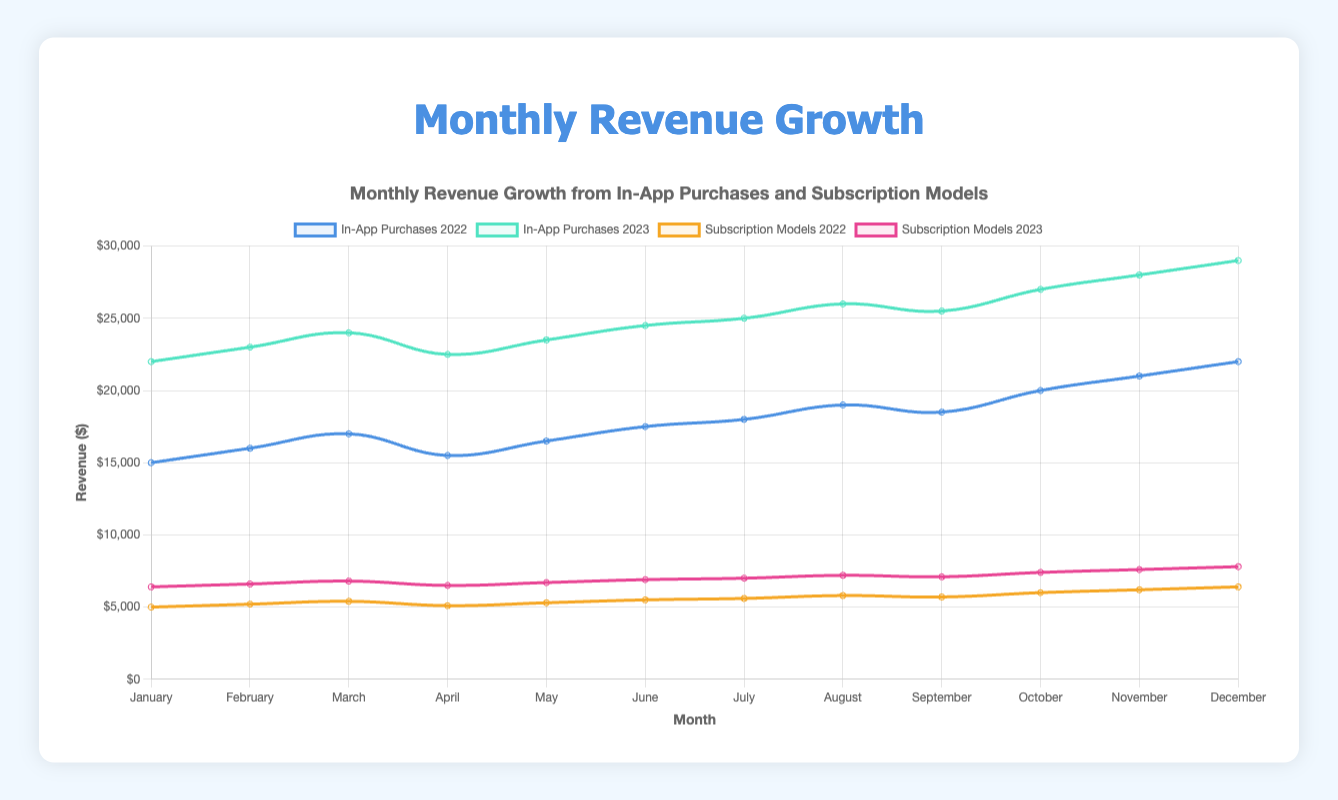What is the total revenue from in-app purchases for February 2023? To find the total revenue from in-app purchases for February 2023, locate February on the x-axis and identify the data point labeled "In-App Purchases 2023". The value is given directly, and it is $23,000.
Answer: $23,000 How does the revenue from subscription models in December 2022 compare to December 2023? To compare the revenue for subscription models in December 2022 and 2023, locate both points on the x-axis under December, observe the y-values: In 2022, it is $6,400, and in 2023, it is $7,800. The 2023 revenue is higher by $1,400.
Answer: 2023 had $1,400 more What is the average monthly revenue for in-app purchases in 2022? The average monthly revenue is calculated by summing all monthly revenues for 2022's in-app purchases and dividing by 12. The sum is $15,000 + $16,000 + $17,000 + $15,500 + $16,500 + $17,500 + $18,000 + $19,000 + $18,500 + $20,000 + $21,000 + $22,000 = $216,000. Dividing by 12 gives $216,000 / 12 = $18,000/month.
Answer: $18,000/month Which model had a higher total revenue in July 2022, in-app purchases or subscription models? To determine which model had a higher revenue in July 2022, find the values for in-app purchases and subscription models for July 2022: $18,000 for in-app purchases and $5,600 for subscription models. The in-app purchases revenue is higher.
Answer: In-app purchases What was the month-on-month revenue growth for in-app purchases from January to February 2023? The month-on-month growth is calculated by subtracting January's revenue from February's revenue, then dividing by January's revenue, finally multiplying by 100 to get the percentage. ((23,000 - 22,000) / 22,000) * 100 = 4.55%.
Answer: 4.55% By how much did the revenue from subscription models increase from April to May 2023? The increase is found by subtracting the April revenue from the May revenue for subscription models: $6,700 (May) - $6,500 (April) = $200.
Answer: $200 What was the highest revenue month for in-app purchases in 2023 and what was the revenue? Identify the highest data point for in-app purchases in 2023 across the months, which is for December 2023 with a revenue of $29,000.
Answer: December, $29,000 How does the revenue change trend for in-app purchases from October 2022 to December 2022 look visually? Visually, the in-app purchases revenue line for 2022 shows an upward trend from October ($20,000) to November ($21,000) to December ($22,000), indicating an increasing revenue.
Answer: Increasing trend If you sum the revenues from in-app purchases and subscription models for the month of August 2023, what is the total amount? Sum the data points for August 2023: in-app purchases ($26,000) + subscription models ($7,200) = $33,200 total revenue.
Answer: $33,200 Which year had higher growth in subscription model revenue from January to December, 2022 or 2023? Calculate the growth by subtracting January revenue from December revenue for each year. In 2022: $6,400 - $5,000 = $1,400. In 2023: $7,800 - $6,400 = $1,400. Both years had the same growth.
Answer: Same growth 